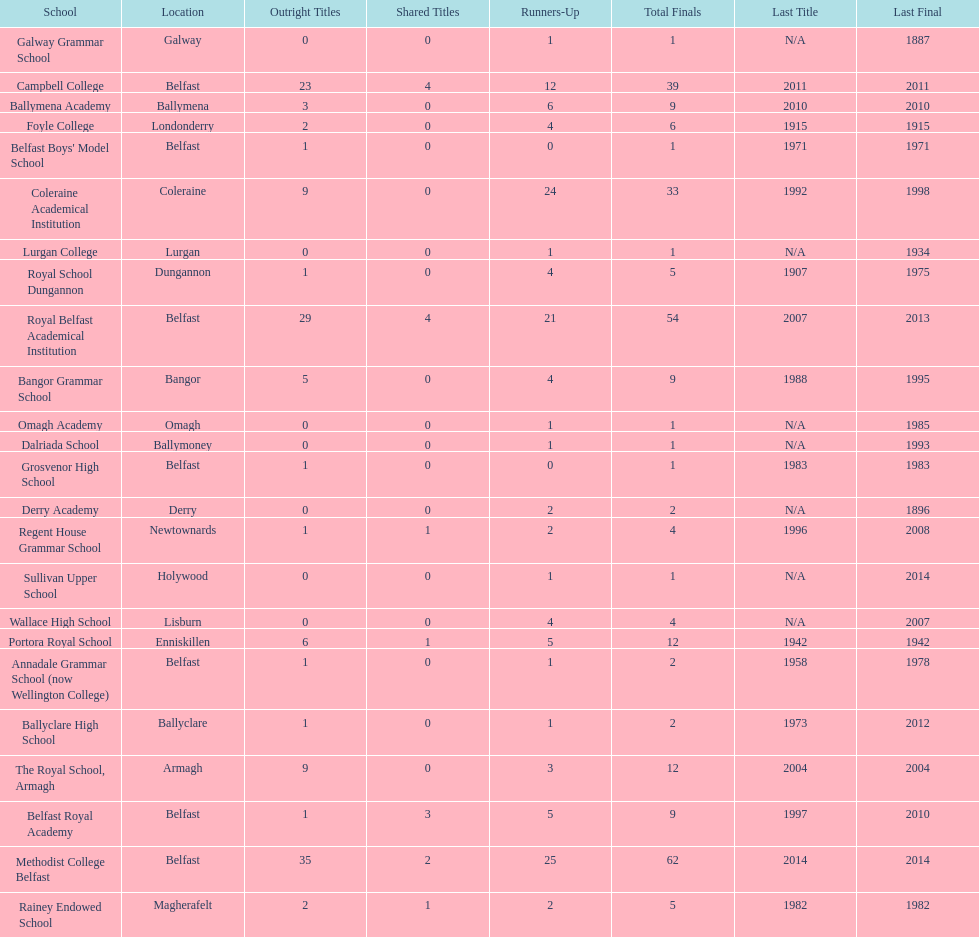What is the difference in runners-up from coleraine academical institution and royal school dungannon? 20. 